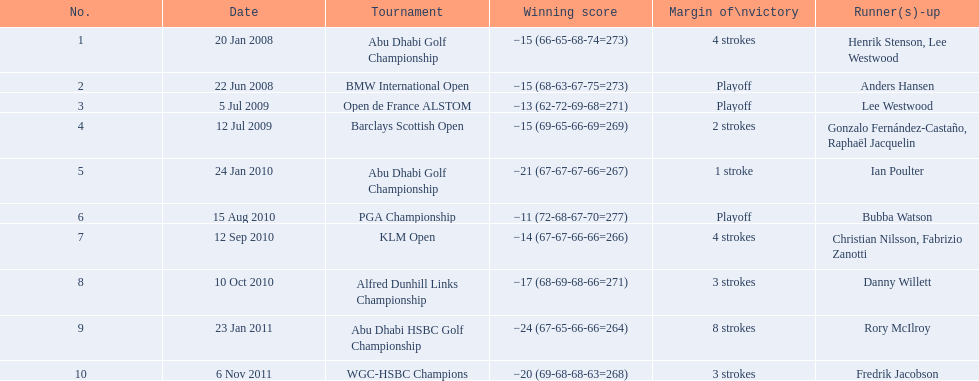How many strokes were in the klm open by martin kaymer? 4 strokes. How many strokes were in the abu dhabi golf championship? 4 strokes. How many more strokes were there in the klm than the barclays open? 2 strokes. 